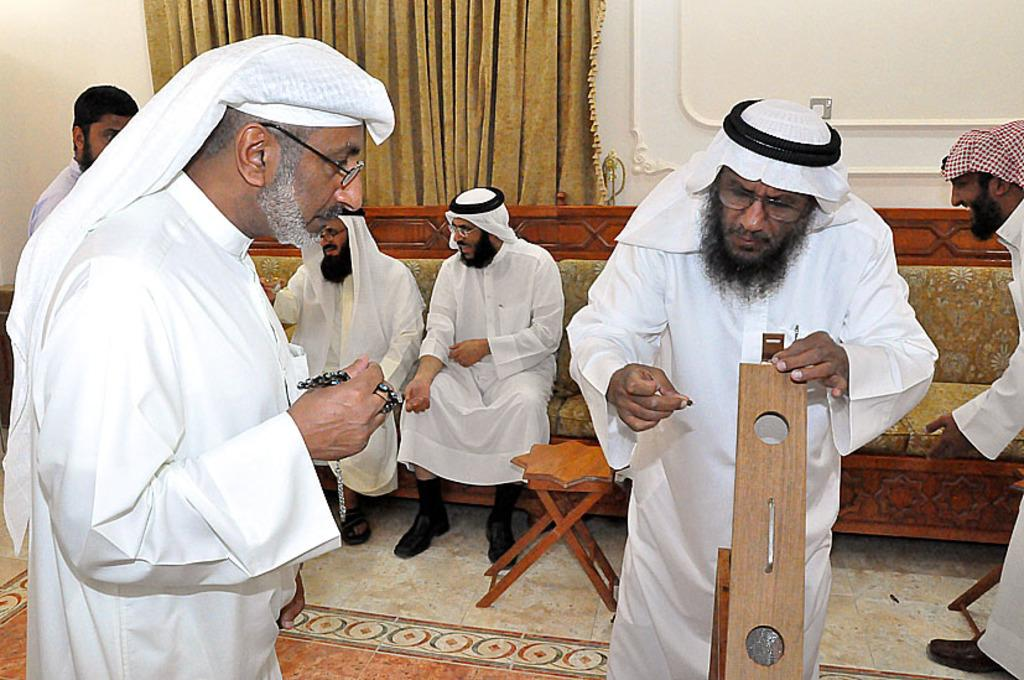What are the people in the image doing? The people in the image are sitting on a sofa. What are the people sitting on the sofa wearing? The people sitting on the sofa are wearing white color dresses. What are the people standing in front of the sofa doing? The standing people are holding something in their hands. Can you tell me how many examples of blades are visible in the image? There are no blades present in the image. Are the people in the image swimming? There is no indication in the image that the people are swimming. 